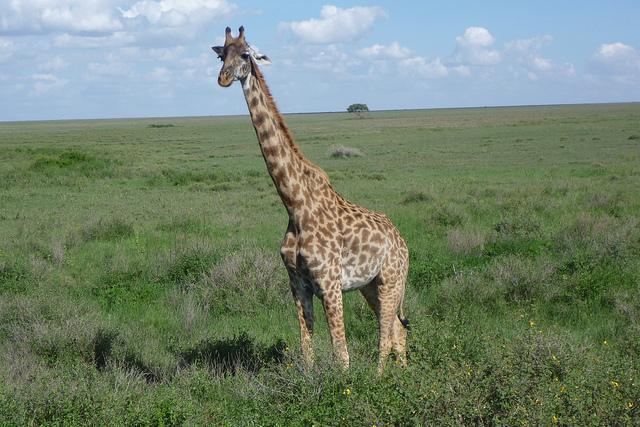How many man sitiing on the elephant?
Give a very brief answer. 0. 